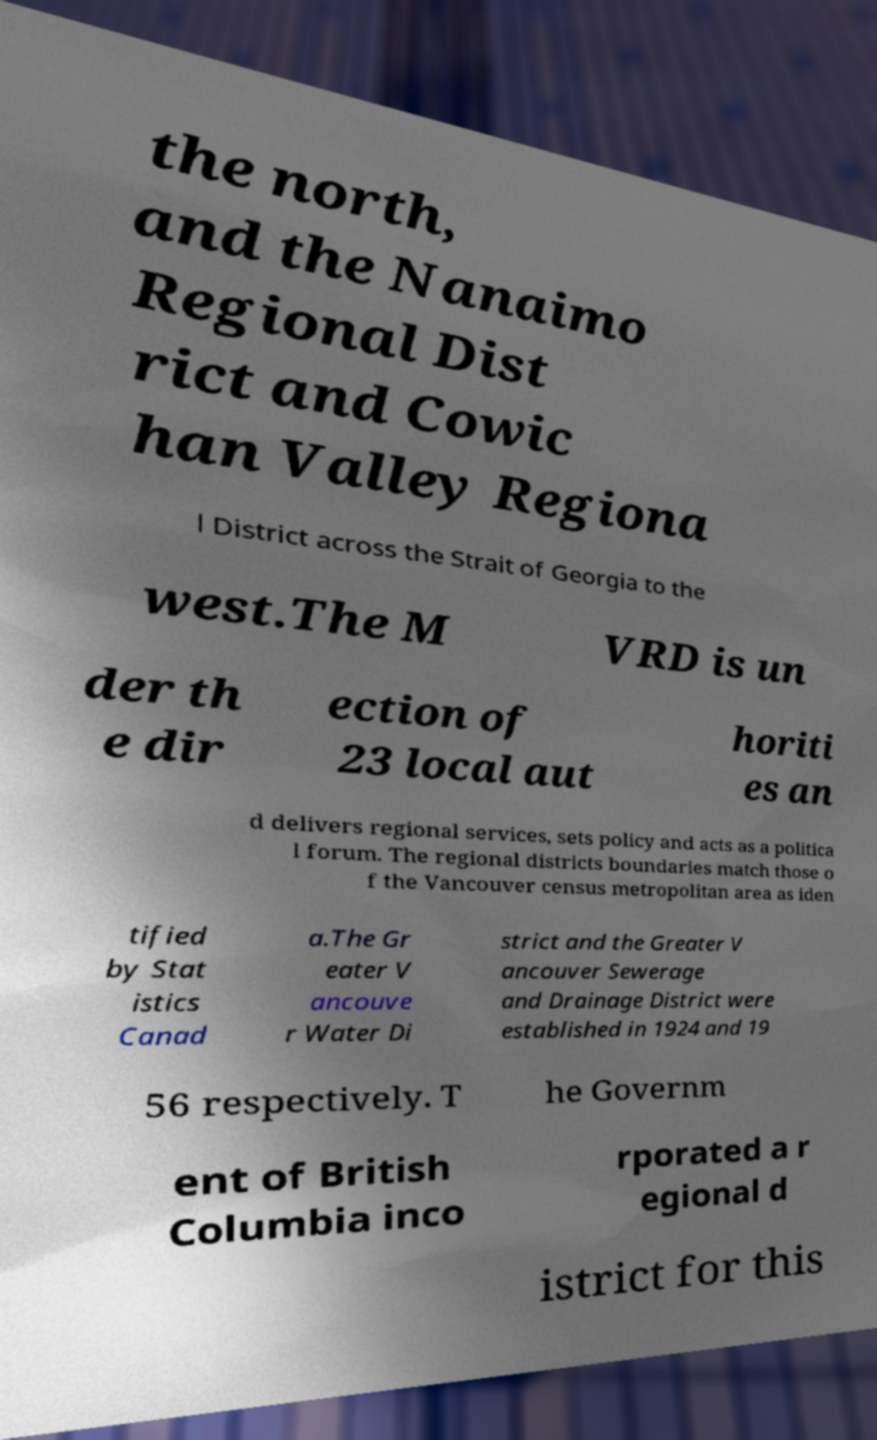Could you extract and type out the text from this image? the north, and the Nanaimo Regional Dist rict and Cowic han Valley Regiona l District across the Strait of Georgia to the west.The M VRD is un der th e dir ection of 23 local aut horiti es an d delivers regional services, sets policy and acts as a politica l forum. The regional districts boundaries match those o f the Vancouver census metropolitan area as iden tified by Stat istics Canad a.The Gr eater V ancouve r Water Di strict and the Greater V ancouver Sewerage and Drainage District were established in 1924 and 19 56 respectively. T he Governm ent of British Columbia inco rporated a r egional d istrict for this 